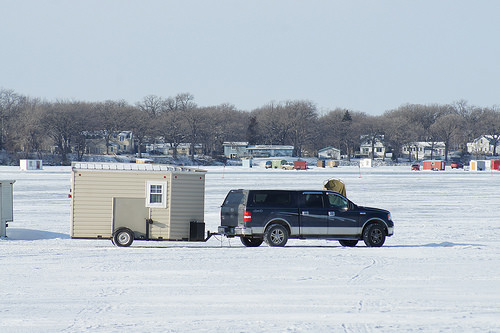<image>
Can you confirm if the house is behind the car? Yes. From this viewpoint, the house is positioned behind the car, with the car partially or fully occluding the house. Where is the truck in relation to the snow? Is it above the snow? No. The truck is not positioned above the snow. The vertical arrangement shows a different relationship. 